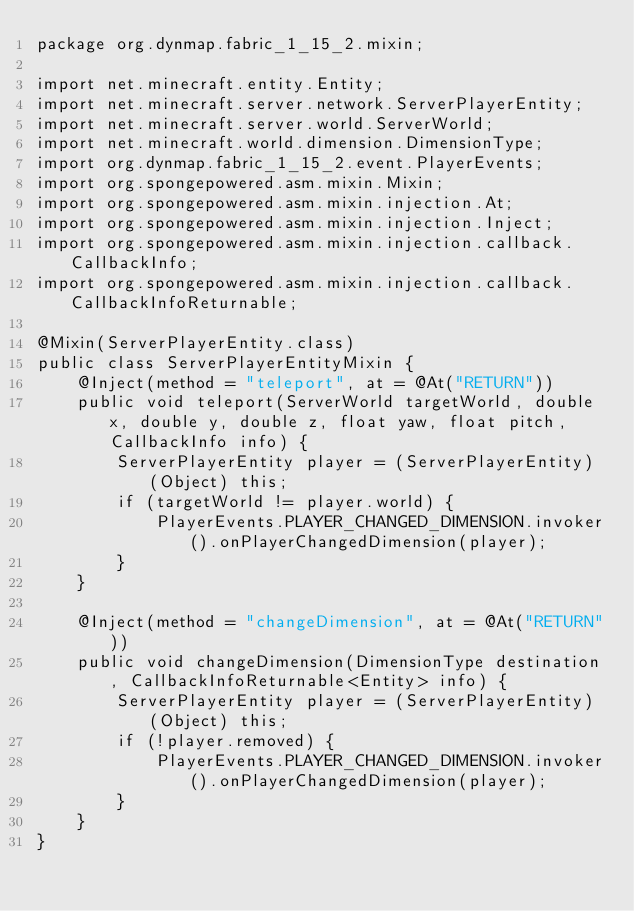<code> <loc_0><loc_0><loc_500><loc_500><_Java_>package org.dynmap.fabric_1_15_2.mixin;

import net.minecraft.entity.Entity;
import net.minecraft.server.network.ServerPlayerEntity;
import net.minecraft.server.world.ServerWorld;
import net.minecraft.world.dimension.DimensionType;
import org.dynmap.fabric_1_15_2.event.PlayerEvents;
import org.spongepowered.asm.mixin.Mixin;
import org.spongepowered.asm.mixin.injection.At;
import org.spongepowered.asm.mixin.injection.Inject;
import org.spongepowered.asm.mixin.injection.callback.CallbackInfo;
import org.spongepowered.asm.mixin.injection.callback.CallbackInfoReturnable;

@Mixin(ServerPlayerEntity.class)
public class ServerPlayerEntityMixin {
    @Inject(method = "teleport", at = @At("RETURN"))
    public void teleport(ServerWorld targetWorld, double x, double y, double z, float yaw, float pitch, CallbackInfo info) {
        ServerPlayerEntity player = (ServerPlayerEntity) (Object) this;
        if (targetWorld != player.world) {
            PlayerEvents.PLAYER_CHANGED_DIMENSION.invoker().onPlayerChangedDimension(player);
        }
    }

    @Inject(method = "changeDimension", at = @At("RETURN"))
    public void changeDimension(DimensionType destination, CallbackInfoReturnable<Entity> info) {
        ServerPlayerEntity player = (ServerPlayerEntity) (Object) this;
        if (!player.removed) {
            PlayerEvents.PLAYER_CHANGED_DIMENSION.invoker().onPlayerChangedDimension(player);
        }
    }
}
</code> 